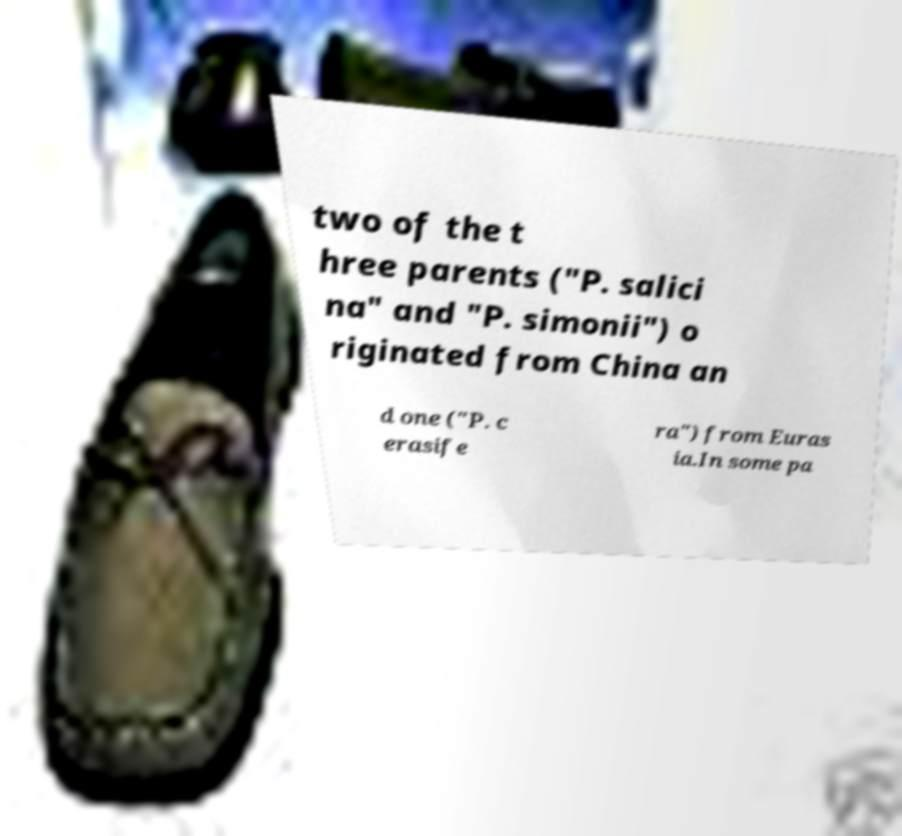For documentation purposes, I need the text within this image transcribed. Could you provide that? two of the t hree parents ("P. salici na" and "P. simonii") o riginated from China an d one ("P. c erasife ra") from Euras ia.In some pa 